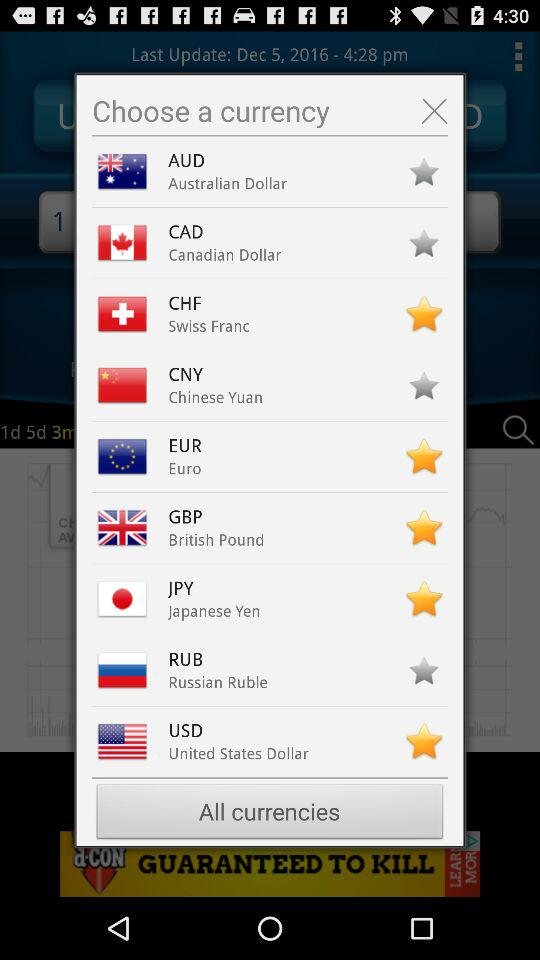Which currencies have not been marked as favorites? The currencies that have not been marked as favorites are Australian Dollar, Canadian Dollar, Chinese Yuan and Russian Ruble. 